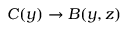<formula> <loc_0><loc_0><loc_500><loc_500>C ( y ) \rightarrow B ( y , z )</formula> 